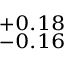<formula> <loc_0><loc_0><loc_500><loc_500>^ { + 0 . 1 8 } _ { - 0 . 1 6 }</formula> 